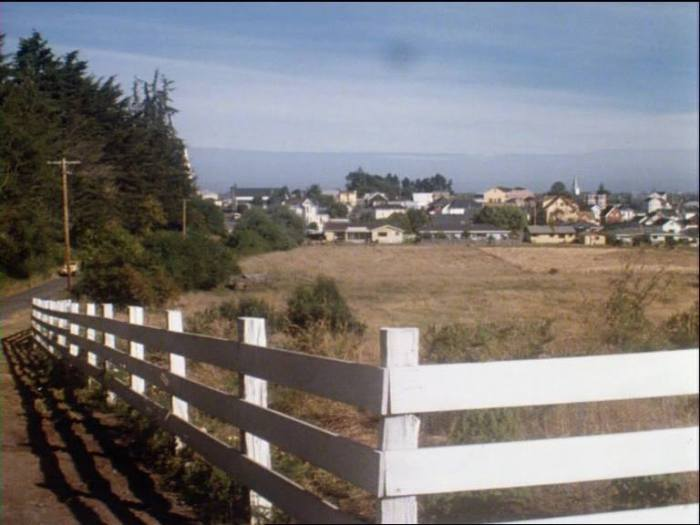Imagine a fairytale set in this location. How would you describe the story and setting? In a quaint little coastal town nestled between lush green forests and a shimmering bay, there lived a young girl named Elara. Elara was not just any girl; she possessed an enchanting ability to communicate with the creatures of both the land and the sea. Her favorite companion was a wise old sea turtle named Alon, who had seen many moons and tides. The townfolk often spoke of a hidden magical grotto deep within the forest, where the waters of the bay met a mystical spring that was said to grant wishes. One day, the peaceful town was threatened by a fierce storm conjured by a spiteful sea witch who held a grudge against the humans for polluting the waters. Determined to save her home, Elara set out on an epic journey with Alon and a band of loyal forest animals to find the grotto and call upon its ancient magic to calm the tempest. Along the way, they faced numerous trials – from navigating enchanted mazes to outsmarting trickster spirits. Their bravery and unity ultimately led them to the magical grotto, where Elara made a heartfelt wish. The grotto’s magic surged through the waters, calming the storm and cleansing the bay. Peace was restored, and the bond between the townfolk and nature was strengthened forever. The tale of Elara became a legend, reminding all who lived by the bay of the power of harmony between humans and the natural world. 